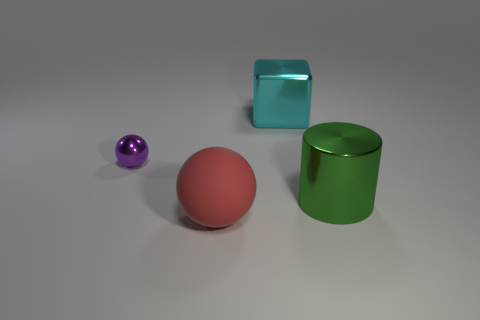Are there any gray spheres of the same size as the green object?
Offer a terse response. No. How many things are either objects on the right side of the cyan thing or big metallic objects in front of the large cyan block?
Provide a short and direct response. 1. There is a cyan object that is the same size as the red matte thing; what is its shape?
Your response must be concise. Cube. Are there any other cyan shiny things of the same shape as the cyan object?
Keep it short and to the point. No. Is the number of big green cylinders less than the number of large brown rubber cylinders?
Ensure brevity in your answer.  No. Is the size of the sphere that is in front of the shiny cylinder the same as the thing that is on the right side of the cyan shiny cube?
Offer a very short reply. Yes. What number of things are either large gray cubes or large green cylinders?
Give a very brief answer. 1. There is a ball that is left of the big red sphere; what size is it?
Your answer should be compact. Small. What number of large red things are to the right of the ball that is in front of the metallic thing on the left side of the large cube?
Provide a short and direct response. 0. How many objects are on the left side of the cyan metal object and right of the big cyan block?
Keep it short and to the point. 0. 